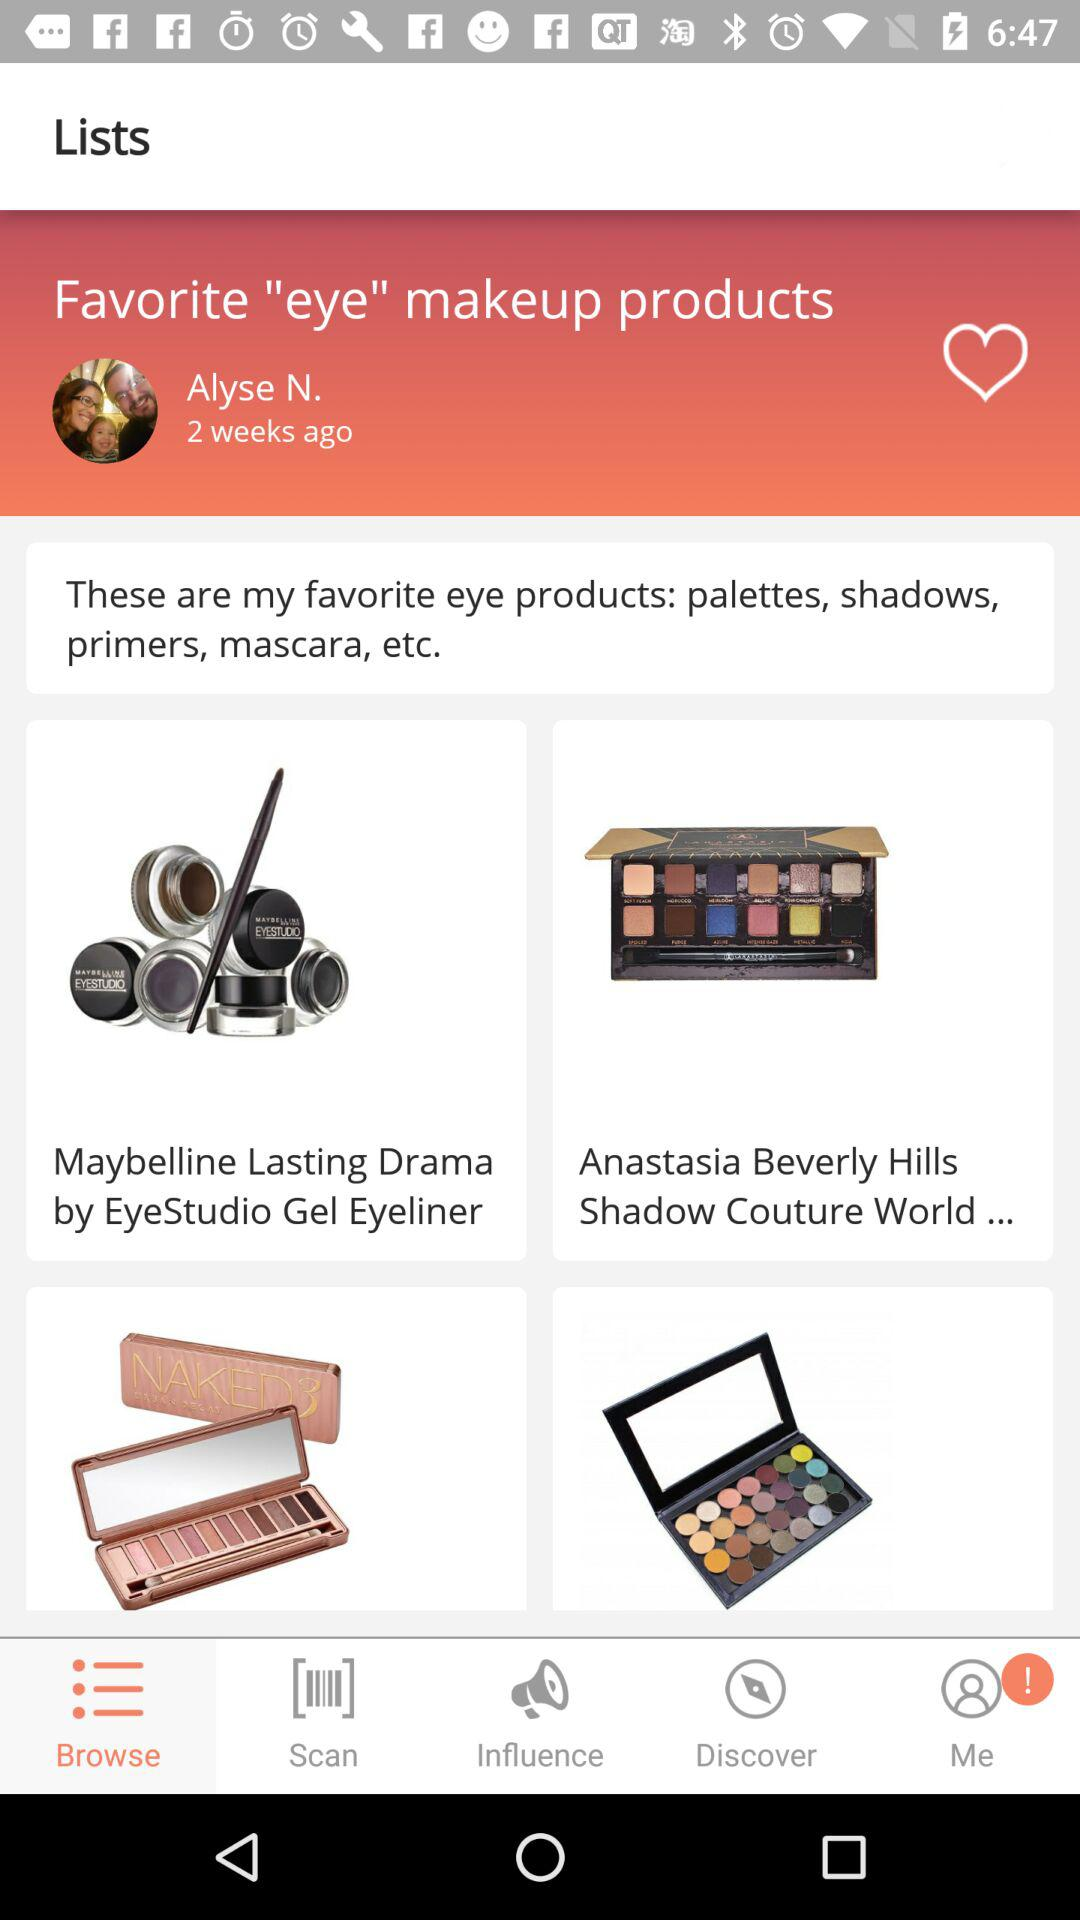When was the post posted by the user? The post was posted 2 weeks ago by the user. 